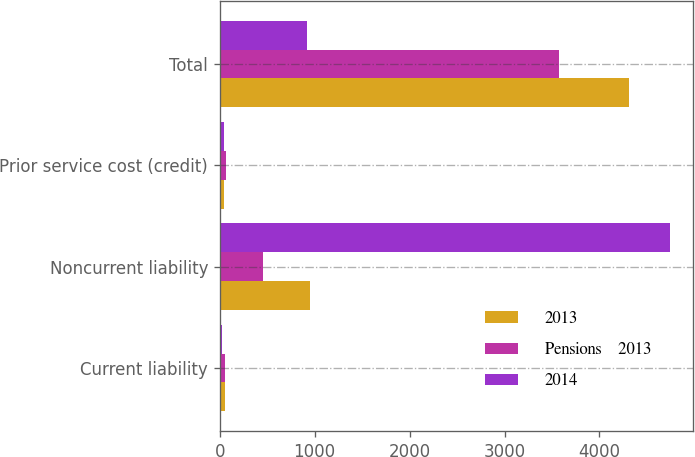Convert chart to OTSL. <chart><loc_0><loc_0><loc_500><loc_500><stacked_bar_chart><ecel><fcel>Current liability<fcel>Noncurrent liability<fcel>Prior service cost (credit)<fcel>Total<nl><fcel>2013<fcel>51<fcel>954<fcel>42<fcel>4308<nl><fcel>Pensions    2013<fcel>58<fcel>453<fcel>67<fcel>3579<nl><fcel>2014<fcel>21<fcel>4748<fcel>41<fcel>919<nl></chart> 